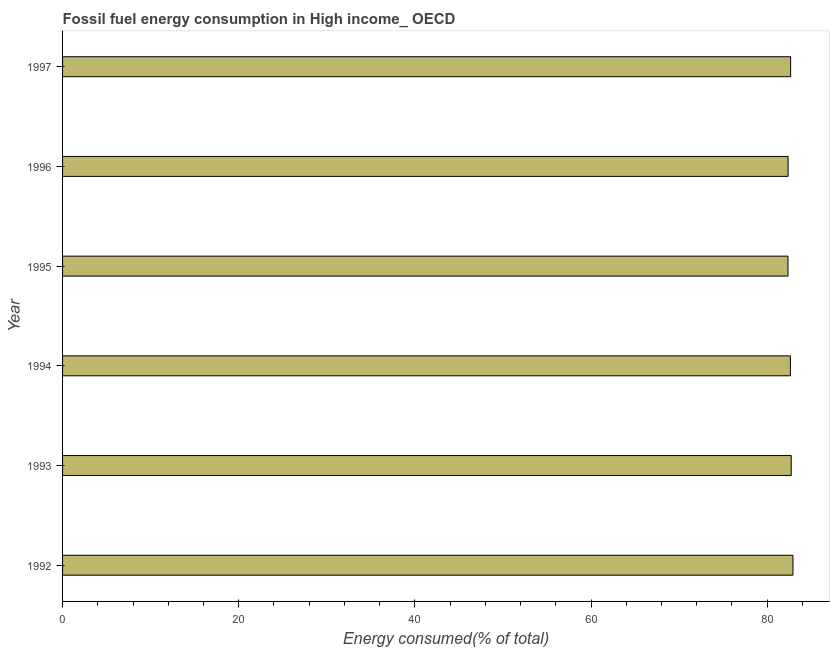Does the graph contain grids?
Give a very brief answer. No. What is the title of the graph?
Your response must be concise. Fossil fuel energy consumption in High income_ OECD. What is the label or title of the X-axis?
Your answer should be very brief. Energy consumed(% of total). What is the fossil fuel energy consumption in 1993?
Keep it short and to the point. 82.73. Across all years, what is the maximum fossil fuel energy consumption?
Your answer should be compact. 82.93. Across all years, what is the minimum fossil fuel energy consumption?
Make the answer very short. 82.37. In which year was the fossil fuel energy consumption maximum?
Provide a succinct answer. 1992. What is the sum of the fossil fuel energy consumption?
Your answer should be very brief. 495.7. What is the difference between the fossil fuel energy consumption in 1994 and 1997?
Offer a very short reply. -0.03. What is the average fossil fuel energy consumption per year?
Offer a terse response. 82.62. What is the median fossil fuel energy consumption?
Offer a very short reply. 82.65. In how many years, is the fossil fuel energy consumption greater than 20 %?
Give a very brief answer. 6. Do a majority of the years between 1992 and 1996 (inclusive) have fossil fuel energy consumption greater than 44 %?
Your answer should be very brief. Yes. Is the difference between the fossil fuel energy consumption in 1993 and 1995 greater than the difference between any two years?
Keep it short and to the point. No. What is the difference between the highest and the second highest fossil fuel energy consumption?
Give a very brief answer. 0.2. Is the sum of the fossil fuel energy consumption in 1996 and 1997 greater than the maximum fossil fuel energy consumption across all years?
Your response must be concise. Yes. What is the difference between the highest and the lowest fossil fuel energy consumption?
Your response must be concise. 0.56. In how many years, is the fossil fuel energy consumption greater than the average fossil fuel energy consumption taken over all years?
Your response must be concise. 4. How many years are there in the graph?
Offer a very short reply. 6. What is the difference between two consecutive major ticks on the X-axis?
Provide a short and direct response. 20. What is the Energy consumed(% of total) in 1992?
Your response must be concise. 82.93. What is the Energy consumed(% of total) of 1993?
Give a very brief answer. 82.73. What is the Energy consumed(% of total) in 1994?
Provide a short and direct response. 82.64. What is the Energy consumed(% of total) in 1995?
Offer a very short reply. 82.37. What is the Energy consumed(% of total) of 1996?
Ensure brevity in your answer.  82.38. What is the Energy consumed(% of total) of 1997?
Your response must be concise. 82.66. What is the difference between the Energy consumed(% of total) in 1992 and 1993?
Ensure brevity in your answer.  0.2. What is the difference between the Energy consumed(% of total) in 1992 and 1994?
Your answer should be very brief. 0.29. What is the difference between the Energy consumed(% of total) in 1992 and 1995?
Offer a terse response. 0.56. What is the difference between the Energy consumed(% of total) in 1992 and 1996?
Provide a succinct answer. 0.55. What is the difference between the Energy consumed(% of total) in 1992 and 1997?
Your answer should be very brief. 0.27. What is the difference between the Energy consumed(% of total) in 1993 and 1994?
Make the answer very short. 0.09. What is the difference between the Energy consumed(% of total) in 1993 and 1995?
Ensure brevity in your answer.  0.36. What is the difference between the Energy consumed(% of total) in 1993 and 1996?
Offer a very short reply. 0.35. What is the difference between the Energy consumed(% of total) in 1993 and 1997?
Your response must be concise. 0.06. What is the difference between the Energy consumed(% of total) in 1994 and 1995?
Provide a short and direct response. 0.27. What is the difference between the Energy consumed(% of total) in 1994 and 1996?
Your answer should be compact. 0.26. What is the difference between the Energy consumed(% of total) in 1994 and 1997?
Provide a succinct answer. -0.03. What is the difference between the Energy consumed(% of total) in 1995 and 1996?
Make the answer very short. -0.01. What is the difference between the Energy consumed(% of total) in 1995 and 1997?
Your response must be concise. -0.3. What is the difference between the Energy consumed(% of total) in 1996 and 1997?
Provide a short and direct response. -0.29. What is the ratio of the Energy consumed(% of total) in 1992 to that in 1993?
Ensure brevity in your answer.  1. What is the ratio of the Energy consumed(% of total) in 1992 to that in 1996?
Give a very brief answer. 1.01. What is the ratio of the Energy consumed(% of total) in 1993 to that in 1997?
Offer a very short reply. 1. What is the ratio of the Energy consumed(% of total) in 1994 to that in 1995?
Provide a short and direct response. 1. What is the ratio of the Energy consumed(% of total) in 1994 to that in 1996?
Keep it short and to the point. 1. 